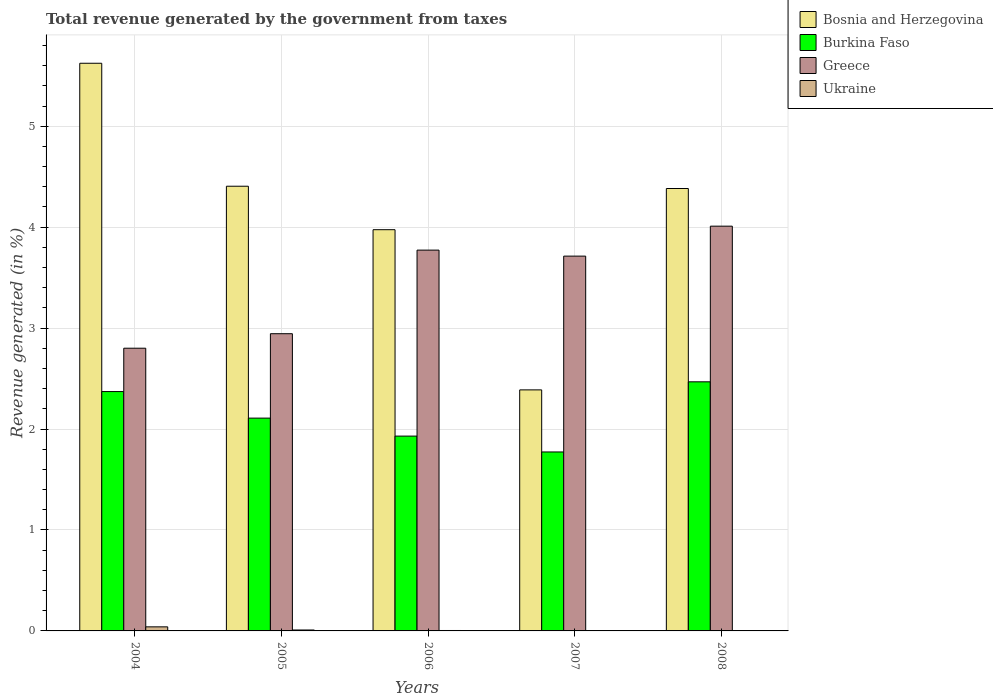How many different coloured bars are there?
Keep it short and to the point. 4. How many groups of bars are there?
Your answer should be very brief. 5. Are the number of bars on each tick of the X-axis equal?
Offer a terse response. Yes. What is the label of the 3rd group of bars from the left?
Provide a succinct answer. 2006. What is the total revenue generated in Ukraine in 2004?
Ensure brevity in your answer.  0.04. Across all years, what is the maximum total revenue generated in Burkina Faso?
Keep it short and to the point. 2.47. Across all years, what is the minimum total revenue generated in Burkina Faso?
Ensure brevity in your answer.  1.77. In which year was the total revenue generated in Burkina Faso minimum?
Keep it short and to the point. 2007. What is the total total revenue generated in Ukraine in the graph?
Your answer should be compact. 0.06. What is the difference between the total revenue generated in Greece in 2004 and that in 2006?
Offer a terse response. -0.97. What is the difference between the total revenue generated in Greece in 2007 and the total revenue generated in Burkina Faso in 2005?
Give a very brief answer. 1.6. What is the average total revenue generated in Greece per year?
Offer a terse response. 3.45. In the year 2005, what is the difference between the total revenue generated in Bosnia and Herzegovina and total revenue generated in Burkina Faso?
Your response must be concise. 2.3. In how many years, is the total revenue generated in Burkina Faso greater than 0.8 %?
Your answer should be compact. 5. What is the ratio of the total revenue generated in Ukraine in 2004 to that in 2007?
Give a very brief answer. 15.6. What is the difference between the highest and the second highest total revenue generated in Bosnia and Herzegovina?
Offer a terse response. 1.22. What is the difference between the highest and the lowest total revenue generated in Ukraine?
Provide a short and direct response. 0.04. Is the sum of the total revenue generated in Bosnia and Herzegovina in 2004 and 2008 greater than the maximum total revenue generated in Greece across all years?
Keep it short and to the point. Yes. Is it the case that in every year, the sum of the total revenue generated in Greece and total revenue generated in Burkina Faso is greater than the sum of total revenue generated in Ukraine and total revenue generated in Bosnia and Herzegovina?
Your answer should be compact. Yes. What does the 2nd bar from the left in 2008 represents?
Your answer should be compact. Burkina Faso. What does the 4th bar from the right in 2004 represents?
Give a very brief answer. Bosnia and Herzegovina. How many bars are there?
Make the answer very short. 20. Are all the bars in the graph horizontal?
Offer a terse response. No. What is the difference between two consecutive major ticks on the Y-axis?
Your response must be concise. 1. Are the values on the major ticks of Y-axis written in scientific E-notation?
Give a very brief answer. No. Does the graph contain any zero values?
Provide a succinct answer. No. Where does the legend appear in the graph?
Provide a succinct answer. Top right. How are the legend labels stacked?
Your answer should be very brief. Vertical. What is the title of the graph?
Your response must be concise. Total revenue generated by the government from taxes. Does "Mauritius" appear as one of the legend labels in the graph?
Offer a terse response. No. What is the label or title of the Y-axis?
Give a very brief answer. Revenue generated (in %). What is the Revenue generated (in %) in Bosnia and Herzegovina in 2004?
Make the answer very short. 5.62. What is the Revenue generated (in %) of Burkina Faso in 2004?
Offer a terse response. 2.37. What is the Revenue generated (in %) of Greece in 2004?
Offer a very short reply. 2.8. What is the Revenue generated (in %) of Ukraine in 2004?
Offer a very short reply. 0.04. What is the Revenue generated (in %) of Bosnia and Herzegovina in 2005?
Offer a terse response. 4.41. What is the Revenue generated (in %) of Burkina Faso in 2005?
Provide a short and direct response. 2.11. What is the Revenue generated (in %) in Greece in 2005?
Provide a succinct answer. 2.94. What is the Revenue generated (in %) in Ukraine in 2005?
Ensure brevity in your answer.  0.01. What is the Revenue generated (in %) of Bosnia and Herzegovina in 2006?
Keep it short and to the point. 3.97. What is the Revenue generated (in %) of Burkina Faso in 2006?
Your answer should be very brief. 1.93. What is the Revenue generated (in %) of Greece in 2006?
Your response must be concise. 3.77. What is the Revenue generated (in %) of Ukraine in 2006?
Your response must be concise. 0. What is the Revenue generated (in %) in Bosnia and Herzegovina in 2007?
Make the answer very short. 2.39. What is the Revenue generated (in %) of Burkina Faso in 2007?
Ensure brevity in your answer.  1.77. What is the Revenue generated (in %) in Greece in 2007?
Offer a very short reply. 3.71. What is the Revenue generated (in %) in Ukraine in 2007?
Your answer should be very brief. 0. What is the Revenue generated (in %) of Bosnia and Herzegovina in 2008?
Provide a short and direct response. 4.38. What is the Revenue generated (in %) of Burkina Faso in 2008?
Provide a succinct answer. 2.47. What is the Revenue generated (in %) in Greece in 2008?
Offer a terse response. 4.01. What is the Revenue generated (in %) of Ukraine in 2008?
Keep it short and to the point. 0. Across all years, what is the maximum Revenue generated (in %) in Bosnia and Herzegovina?
Offer a terse response. 5.62. Across all years, what is the maximum Revenue generated (in %) of Burkina Faso?
Keep it short and to the point. 2.47. Across all years, what is the maximum Revenue generated (in %) in Greece?
Ensure brevity in your answer.  4.01. Across all years, what is the maximum Revenue generated (in %) of Ukraine?
Provide a short and direct response. 0.04. Across all years, what is the minimum Revenue generated (in %) in Bosnia and Herzegovina?
Your answer should be very brief. 2.39. Across all years, what is the minimum Revenue generated (in %) of Burkina Faso?
Give a very brief answer. 1.77. Across all years, what is the minimum Revenue generated (in %) in Greece?
Your response must be concise. 2.8. Across all years, what is the minimum Revenue generated (in %) in Ukraine?
Provide a short and direct response. 0. What is the total Revenue generated (in %) in Bosnia and Herzegovina in the graph?
Offer a terse response. 20.77. What is the total Revenue generated (in %) in Burkina Faso in the graph?
Keep it short and to the point. 10.65. What is the total Revenue generated (in %) in Greece in the graph?
Your answer should be compact. 17.24. What is the total Revenue generated (in %) of Ukraine in the graph?
Give a very brief answer. 0.06. What is the difference between the Revenue generated (in %) in Bosnia and Herzegovina in 2004 and that in 2005?
Ensure brevity in your answer.  1.22. What is the difference between the Revenue generated (in %) in Burkina Faso in 2004 and that in 2005?
Your answer should be very brief. 0.26. What is the difference between the Revenue generated (in %) in Greece in 2004 and that in 2005?
Give a very brief answer. -0.14. What is the difference between the Revenue generated (in %) in Ukraine in 2004 and that in 2005?
Offer a very short reply. 0.03. What is the difference between the Revenue generated (in %) in Bosnia and Herzegovina in 2004 and that in 2006?
Your response must be concise. 1.65. What is the difference between the Revenue generated (in %) in Burkina Faso in 2004 and that in 2006?
Keep it short and to the point. 0.44. What is the difference between the Revenue generated (in %) in Greece in 2004 and that in 2006?
Keep it short and to the point. -0.97. What is the difference between the Revenue generated (in %) in Ukraine in 2004 and that in 2006?
Make the answer very short. 0.04. What is the difference between the Revenue generated (in %) of Bosnia and Herzegovina in 2004 and that in 2007?
Make the answer very short. 3.24. What is the difference between the Revenue generated (in %) in Burkina Faso in 2004 and that in 2007?
Offer a terse response. 0.6. What is the difference between the Revenue generated (in %) of Greece in 2004 and that in 2007?
Offer a terse response. -0.91. What is the difference between the Revenue generated (in %) in Ukraine in 2004 and that in 2007?
Provide a succinct answer. 0.04. What is the difference between the Revenue generated (in %) of Bosnia and Herzegovina in 2004 and that in 2008?
Make the answer very short. 1.24. What is the difference between the Revenue generated (in %) of Burkina Faso in 2004 and that in 2008?
Your response must be concise. -0.1. What is the difference between the Revenue generated (in %) of Greece in 2004 and that in 2008?
Give a very brief answer. -1.21. What is the difference between the Revenue generated (in %) in Ukraine in 2004 and that in 2008?
Offer a very short reply. 0.04. What is the difference between the Revenue generated (in %) of Bosnia and Herzegovina in 2005 and that in 2006?
Provide a succinct answer. 0.43. What is the difference between the Revenue generated (in %) of Burkina Faso in 2005 and that in 2006?
Offer a terse response. 0.18. What is the difference between the Revenue generated (in %) in Greece in 2005 and that in 2006?
Keep it short and to the point. -0.83. What is the difference between the Revenue generated (in %) in Ukraine in 2005 and that in 2006?
Your response must be concise. 0.01. What is the difference between the Revenue generated (in %) in Bosnia and Herzegovina in 2005 and that in 2007?
Offer a terse response. 2.02. What is the difference between the Revenue generated (in %) in Burkina Faso in 2005 and that in 2007?
Make the answer very short. 0.34. What is the difference between the Revenue generated (in %) of Greece in 2005 and that in 2007?
Offer a terse response. -0.77. What is the difference between the Revenue generated (in %) of Ukraine in 2005 and that in 2007?
Your answer should be very brief. 0.01. What is the difference between the Revenue generated (in %) of Bosnia and Herzegovina in 2005 and that in 2008?
Provide a succinct answer. 0.02. What is the difference between the Revenue generated (in %) of Burkina Faso in 2005 and that in 2008?
Give a very brief answer. -0.36. What is the difference between the Revenue generated (in %) in Greece in 2005 and that in 2008?
Offer a terse response. -1.07. What is the difference between the Revenue generated (in %) of Ukraine in 2005 and that in 2008?
Keep it short and to the point. 0.01. What is the difference between the Revenue generated (in %) in Bosnia and Herzegovina in 2006 and that in 2007?
Offer a terse response. 1.59. What is the difference between the Revenue generated (in %) of Burkina Faso in 2006 and that in 2007?
Offer a terse response. 0.16. What is the difference between the Revenue generated (in %) in Greece in 2006 and that in 2007?
Make the answer very short. 0.06. What is the difference between the Revenue generated (in %) of Ukraine in 2006 and that in 2007?
Offer a very short reply. 0. What is the difference between the Revenue generated (in %) of Bosnia and Herzegovina in 2006 and that in 2008?
Offer a terse response. -0.41. What is the difference between the Revenue generated (in %) of Burkina Faso in 2006 and that in 2008?
Offer a terse response. -0.54. What is the difference between the Revenue generated (in %) in Greece in 2006 and that in 2008?
Your answer should be compact. -0.24. What is the difference between the Revenue generated (in %) of Ukraine in 2006 and that in 2008?
Provide a short and direct response. 0. What is the difference between the Revenue generated (in %) of Bosnia and Herzegovina in 2007 and that in 2008?
Provide a succinct answer. -2. What is the difference between the Revenue generated (in %) in Burkina Faso in 2007 and that in 2008?
Keep it short and to the point. -0.69. What is the difference between the Revenue generated (in %) of Greece in 2007 and that in 2008?
Keep it short and to the point. -0.3. What is the difference between the Revenue generated (in %) of Ukraine in 2007 and that in 2008?
Your response must be concise. 0. What is the difference between the Revenue generated (in %) of Bosnia and Herzegovina in 2004 and the Revenue generated (in %) of Burkina Faso in 2005?
Offer a very short reply. 3.52. What is the difference between the Revenue generated (in %) in Bosnia and Herzegovina in 2004 and the Revenue generated (in %) in Greece in 2005?
Offer a very short reply. 2.68. What is the difference between the Revenue generated (in %) in Bosnia and Herzegovina in 2004 and the Revenue generated (in %) in Ukraine in 2005?
Provide a short and direct response. 5.61. What is the difference between the Revenue generated (in %) of Burkina Faso in 2004 and the Revenue generated (in %) of Greece in 2005?
Give a very brief answer. -0.57. What is the difference between the Revenue generated (in %) in Burkina Faso in 2004 and the Revenue generated (in %) in Ukraine in 2005?
Keep it short and to the point. 2.36. What is the difference between the Revenue generated (in %) in Greece in 2004 and the Revenue generated (in %) in Ukraine in 2005?
Offer a terse response. 2.79. What is the difference between the Revenue generated (in %) of Bosnia and Herzegovina in 2004 and the Revenue generated (in %) of Burkina Faso in 2006?
Your response must be concise. 3.69. What is the difference between the Revenue generated (in %) in Bosnia and Herzegovina in 2004 and the Revenue generated (in %) in Greece in 2006?
Offer a terse response. 1.85. What is the difference between the Revenue generated (in %) in Bosnia and Herzegovina in 2004 and the Revenue generated (in %) in Ukraine in 2006?
Ensure brevity in your answer.  5.62. What is the difference between the Revenue generated (in %) of Burkina Faso in 2004 and the Revenue generated (in %) of Greece in 2006?
Keep it short and to the point. -1.4. What is the difference between the Revenue generated (in %) in Burkina Faso in 2004 and the Revenue generated (in %) in Ukraine in 2006?
Your answer should be very brief. 2.37. What is the difference between the Revenue generated (in %) in Greece in 2004 and the Revenue generated (in %) in Ukraine in 2006?
Make the answer very short. 2.8. What is the difference between the Revenue generated (in %) of Bosnia and Herzegovina in 2004 and the Revenue generated (in %) of Burkina Faso in 2007?
Your answer should be compact. 3.85. What is the difference between the Revenue generated (in %) in Bosnia and Herzegovina in 2004 and the Revenue generated (in %) in Greece in 2007?
Provide a short and direct response. 1.91. What is the difference between the Revenue generated (in %) in Bosnia and Herzegovina in 2004 and the Revenue generated (in %) in Ukraine in 2007?
Offer a very short reply. 5.62. What is the difference between the Revenue generated (in %) in Burkina Faso in 2004 and the Revenue generated (in %) in Greece in 2007?
Provide a short and direct response. -1.34. What is the difference between the Revenue generated (in %) in Burkina Faso in 2004 and the Revenue generated (in %) in Ukraine in 2007?
Keep it short and to the point. 2.37. What is the difference between the Revenue generated (in %) in Greece in 2004 and the Revenue generated (in %) in Ukraine in 2007?
Your answer should be very brief. 2.8. What is the difference between the Revenue generated (in %) in Bosnia and Herzegovina in 2004 and the Revenue generated (in %) in Burkina Faso in 2008?
Give a very brief answer. 3.16. What is the difference between the Revenue generated (in %) in Bosnia and Herzegovina in 2004 and the Revenue generated (in %) in Greece in 2008?
Keep it short and to the point. 1.61. What is the difference between the Revenue generated (in %) in Bosnia and Herzegovina in 2004 and the Revenue generated (in %) in Ukraine in 2008?
Make the answer very short. 5.62. What is the difference between the Revenue generated (in %) in Burkina Faso in 2004 and the Revenue generated (in %) in Greece in 2008?
Your answer should be compact. -1.64. What is the difference between the Revenue generated (in %) of Burkina Faso in 2004 and the Revenue generated (in %) of Ukraine in 2008?
Your answer should be very brief. 2.37. What is the difference between the Revenue generated (in %) in Greece in 2004 and the Revenue generated (in %) in Ukraine in 2008?
Your answer should be compact. 2.8. What is the difference between the Revenue generated (in %) in Bosnia and Herzegovina in 2005 and the Revenue generated (in %) in Burkina Faso in 2006?
Your answer should be very brief. 2.48. What is the difference between the Revenue generated (in %) of Bosnia and Herzegovina in 2005 and the Revenue generated (in %) of Greece in 2006?
Ensure brevity in your answer.  0.63. What is the difference between the Revenue generated (in %) of Bosnia and Herzegovina in 2005 and the Revenue generated (in %) of Ukraine in 2006?
Give a very brief answer. 4.4. What is the difference between the Revenue generated (in %) in Burkina Faso in 2005 and the Revenue generated (in %) in Greece in 2006?
Your answer should be very brief. -1.66. What is the difference between the Revenue generated (in %) of Burkina Faso in 2005 and the Revenue generated (in %) of Ukraine in 2006?
Make the answer very short. 2.1. What is the difference between the Revenue generated (in %) in Greece in 2005 and the Revenue generated (in %) in Ukraine in 2006?
Your answer should be compact. 2.94. What is the difference between the Revenue generated (in %) in Bosnia and Herzegovina in 2005 and the Revenue generated (in %) in Burkina Faso in 2007?
Your response must be concise. 2.63. What is the difference between the Revenue generated (in %) in Bosnia and Herzegovina in 2005 and the Revenue generated (in %) in Greece in 2007?
Provide a short and direct response. 0.69. What is the difference between the Revenue generated (in %) in Bosnia and Herzegovina in 2005 and the Revenue generated (in %) in Ukraine in 2007?
Keep it short and to the point. 4.4. What is the difference between the Revenue generated (in %) of Burkina Faso in 2005 and the Revenue generated (in %) of Greece in 2007?
Offer a terse response. -1.6. What is the difference between the Revenue generated (in %) in Burkina Faso in 2005 and the Revenue generated (in %) in Ukraine in 2007?
Offer a terse response. 2.11. What is the difference between the Revenue generated (in %) of Greece in 2005 and the Revenue generated (in %) of Ukraine in 2007?
Your response must be concise. 2.94. What is the difference between the Revenue generated (in %) of Bosnia and Herzegovina in 2005 and the Revenue generated (in %) of Burkina Faso in 2008?
Your answer should be very brief. 1.94. What is the difference between the Revenue generated (in %) of Bosnia and Herzegovina in 2005 and the Revenue generated (in %) of Greece in 2008?
Give a very brief answer. 0.4. What is the difference between the Revenue generated (in %) of Bosnia and Herzegovina in 2005 and the Revenue generated (in %) of Ukraine in 2008?
Give a very brief answer. 4.4. What is the difference between the Revenue generated (in %) in Burkina Faso in 2005 and the Revenue generated (in %) in Greece in 2008?
Provide a succinct answer. -1.9. What is the difference between the Revenue generated (in %) in Burkina Faso in 2005 and the Revenue generated (in %) in Ukraine in 2008?
Provide a short and direct response. 2.11. What is the difference between the Revenue generated (in %) of Greece in 2005 and the Revenue generated (in %) of Ukraine in 2008?
Offer a terse response. 2.94. What is the difference between the Revenue generated (in %) in Bosnia and Herzegovina in 2006 and the Revenue generated (in %) in Burkina Faso in 2007?
Provide a succinct answer. 2.2. What is the difference between the Revenue generated (in %) in Bosnia and Herzegovina in 2006 and the Revenue generated (in %) in Greece in 2007?
Provide a succinct answer. 0.26. What is the difference between the Revenue generated (in %) of Bosnia and Herzegovina in 2006 and the Revenue generated (in %) of Ukraine in 2007?
Keep it short and to the point. 3.97. What is the difference between the Revenue generated (in %) in Burkina Faso in 2006 and the Revenue generated (in %) in Greece in 2007?
Offer a terse response. -1.78. What is the difference between the Revenue generated (in %) of Burkina Faso in 2006 and the Revenue generated (in %) of Ukraine in 2007?
Provide a succinct answer. 1.93. What is the difference between the Revenue generated (in %) of Greece in 2006 and the Revenue generated (in %) of Ukraine in 2007?
Keep it short and to the point. 3.77. What is the difference between the Revenue generated (in %) in Bosnia and Herzegovina in 2006 and the Revenue generated (in %) in Burkina Faso in 2008?
Offer a terse response. 1.51. What is the difference between the Revenue generated (in %) in Bosnia and Herzegovina in 2006 and the Revenue generated (in %) in Greece in 2008?
Provide a short and direct response. -0.04. What is the difference between the Revenue generated (in %) in Bosnia and Herzegovina in 2006 and the Revenue generated (in %) in Ukraine in 2008?
Your answer should be compact. 3.97. What is the difference between the Revenue generated (in %) in Burkina Faso in 2006 and the Revenue generated (in %) in Greece in 2008?
Your answer should be compact. -2.08. What is the difference between the Revenue generated (in %) in Burkina Faso in 2006 and the Revenue generated (in %) in Ukraine in 2008?
Make the answer very short. 1.93. What is the difference between the Revenue generated (in %) of Greece in 2006 and the Revenue generated (in %) of Ukraine in 2008?
Make the answer very short. 3.77. What is the difference between the Revenue generated (in %) in Bosnia and Herzegovina in 2007 and the Revenue generated (in %) in Burkina Faso in 2008?
Make the answer very short. -0.08. What is the difference between the Revenue generated (in %) of Bosnia and Herzegovina in 2007 and the Revenue generated (in %) of Greece in 2008?
Offer a very short reply. -1.62. What is the difference between the Revenue generated (in %) in Bosnia and Herzegovina in 2007 and the Revenue generated (in %) in Ukraine in 2008?
Your answer should be compact. 2.39. What is the difference between the Revenue generated (in %) of Burkina Faso in 2007 and the Revenue generated (in %) of Greece in 2008?
Your answer should be compact. -2.24. What is the difference between the Revenue generated (in %) in Burkina Faso in 2007 and the Revenue generated (in %) in Ukraine in 2008?
Keep it short and to the point. 1.77. What is the difference between the Revenue generated (in %) of Greece in 2007 and the Revenue generated (in %) of Ukraine in 2008?
Keep it short and to the point. 3.71. What is the average Revenue generated (in %) in Bosnia and Herzegovina per year?
Provide a short and direct response. 4.16. What is the average Revenue generated (in %) in Burkina Faso per year?
Provide a short and direct response. 2.13. What is the average Revenue generated (in %) in Greece per year?
Keep it short and to the point. 3.45. What is the average Revenue generated (in %) in Ukraine per year?
Ensure brevity in your answer.  0.01. In the year 2004, what is the difference between the Revenue generated (in %) of Bosnia and Herzegovina and Revenue generated (in %) of Burkina Faso?
Keep it short and to the point. 3.25. In the year 2004, what is the difference between the Revenue generated (in %) in Bosnia and Herzegovina and Revenue generated (in %) in Greece?
Give a very brief answer. 2.82. In the year 2004, what is the difference between the Revenue generated (in %) in Bosnia and Herzegovina and Revenue generated (in %) in Ukraine?
Give a very brief answer. 5.58. In the year 2004, what is the difference between the Revenue generated (in %) in Burkina Faso and Revenue generated (in %) in Greece?
Your answer should be very brief. -0.43. In the year 2004, what is the difference between the Revenue generated (in %) in Burkina Faso and Revenue generated (in %) in Ukraine?
Offer a terse response. 2.33. In the year 2004, what is the difference between the Revenue generated (in %) of Greece and Revenue generated (in %) of Ukraine?
Offer a very short reply. 2.76. In the year 2005, what is the difference between the Revenue generated (in %) in Bosnia and Herzegovina and Revenue generated (in %) in Burkina Faso?
Your answer should be compact. 2.3. In the year 2005, what is the difference between the Revenue generated (in %) of Bosnia and Herzegovina and Revenue generated (in %) of Greece?
Keep it short and to the point. 1.46. In the year 2005, what is the difference between the Revenue generated (in %) in Bosnia and Herzegovina and Revenue generated (in %) in Ukraine?
Ensure brevity in your answer.  4.4. In the year 2005, what is the difference between the Revenue generated (in %) of Burkina Faso and Revenue generated (in %) of Greece?
Ensure brevity in your answer.  -0.84. In the year 2005, what is the difference between the Revenue generated (in %) in Burkina Faso and Revenue generated (in %) in Ukraine?
Provide a succinct answer. 2.1. In the year 2005, what is the difference between the Revenue generated (in %) in Greece and Revenue generated (in %) in Ukraine?
Provide a succinct answer. 2.94. In the year 2006, what is the difference between the Revenue generated (in %) in Bosnia and Herzegovina and Revenue generated (in %) in Burkina Faso?
Ensure brevity in your answer.  2.04. In the year 2006, what is the difference between the Revenue generated (in %) of Bosnia and Herzegovina and Revenue generated (in %) of Greece?
Your answer should be compact. 0.2. In the year 2006, what is the difference between the Revenue generated (in %) in Bosnia and Herzegovina and Revenue generated (in %) in Ukraine?
Keep it short and to the point. 3.97. In the year 2006, what is the difference between the Revenue generated (in %) in Burkina Faso and Revenue generated (in %) in Greece?
Provide a succinct answer. -1.84. In the year 2006, what is the difference between the Revenue generated (in %) of Burkina Faso and Revenue generated (in %) of Ukraine?
Your answer should be compact. 1.93. In the year 2006, what is the difference between the Revenue generated (in %) in Greece and Revenue generated (in %) in Ukraine?
Keep it short and to the point. 3.77. In the year 2007, what is the difference between the Revenue generated (in %) of Bosnia and Herzegovina and Revenue generated (in %) of Burkina Faso?
Provide a succinct answer. 0.61. In the year 2007, what is the difference between the Revenue generated (in %) of Bosnia and Herzegovina and Revenue generated (in %) of Greece?
Your answer should be compact. -1.33. In the year 2007, what is the difference between the Revenue generated (in %) of Bosnia and Herzegovina and Revenue generated (in %) of Ukraine?
Your answer should be compact. 2.39. In the year 2007, what is the difference between the Revenue generated (in %) in Burkina Faso and Revenue generated (in %) in Greece?
Ensure brevity in your answer.  -1.94. In the year 2007, what is the difference between the Revenue generated (in %) of Burkina Faso and Revenue generated (in %) of Ukraine?
Offer a very short reply. 1.77. In the year 2007, what is the difference between the Revenue generated (in %) of Greece and Revenue generated (in %) of Ukraine?
Your response must be concise. 3.71. In the year 2008, what is the difference between the Revenue generated (in %) in Bosnia and Herzegovina and Revenue generated (in %) in Burkina Faso?
Offer a very short reply. 1.92. In the year 2008, what is the difference between the Revenue generated (in %) in Bosnia and Herzegovina and Revenue generated (in %) in Greece?
Offer a very short reply. 0.37. In the year 2008, what is the difference between the Revenue generated (in %) of Bosnia and Herzegovina and Revenue generated (in %) of Ukraine?
Give a very brief answer. 4.38. In the year 2008, what is the difference between the Revenue generated (in %) in Burkina Faso and Revenue generated (in %) in Greece?
Make the answer very short. -1.54. In the year 2008, what is the difference between the Revenue generated (in %) in Burkina Faso and Revenue generated (in %) in Ukraine?
Offer a terse response. 2.47. In the year 2008, what is the difference between the Revenue generated (in %) of Greece and Revenue generated (in %) of Ukraine?
Offer a very short reply. 4.01. What is the ratio of the Revenue generated (in %) in Bosnia and Herzegovina in 2004 to that in 2005?
Your answer should be very brief. 1.28. What is the ratio of the Revenue generated (in %) of Burkina Faso in 2004 to that in 2005?
Give a very brief answer. 1.12. What is the ratio of the Revenue generated (in %) in Greece in 2004 to that in 2005?
Ensure brevity in your answer.  0.95. What is the ratio of the Revenue generated (in %) in Ukraine in 2004 to that in 2005?
Provide a short and direct response. 4.38. What is the ratio of the Revenue generated (in %) in Bosnia and Herzegovina in 2004 to that in 2006?
Give a very brief answer. 1.41. What is the ratio of the Revenue generated (in %) of Burkina Faso in 2004 to that in 2006?
Make the answer very short. 1.23. What is the ratio of the Revenue generated (in %) in Greece in 2004 to that in 2006?
Keep it short and to the point. 0.74. What is the ratio of the Revenue generated (in %) of Ukraine in 2004 to that in 2006?
Offer a terse response. 9.53. What is the ratio of the Revenue generated (in %) in Bosnia and Herzegovina in 2004 to that in 2007?
Make the answer very short. 2.36. What is the ratio of the Revenue generated (in %) in Burkina Faso in 2004 to that in 2007?
Provide a short and direct response. 1.34. What is the ratio of the Revenue generated (in %) of Greece in 2004 to that in 2007?
Provide a short and direct response. 0.75. What is the ratio of the Revenue generated (in %) of Ukraine in 2004 to that in 2007?
Your answer should be compact. 15.6. What is the ratio of the Revenue generated (in %) of Bosnia and Herzegovina in 2004 to that in 2008?
Your answer should be very brief. 1.28. What is the ratio of the Revenue generated (in %) in Burkina Faso in 2004 to that in 2008?
Your answer should be compact. 0.96. What is the ratio of the Revenue generated (in %) of Greece in 2004 to that in 2008?
Keep it short and to the point. 0.7. What is the ratio of the Revenue generated (in %) of Ukraine in 2004 to that in 2008?
Ensure brevity in your answer.  40.67. What is the ratio of the Revenue generated (in %) of Bosnia and Herzegovina in 2005 to that in 2006?
Your answer should be very brief. 1.11. What is the ratio of the Revenue generated (in %) of Burkina Faso in 2005 to that in 2006?
Ensure brevity in your answer.  1.09. What is the ratio of the Revenue generated (in %) of Greece in 2005 to that in 2006?
Your answer should be compact. 0.78. What is the ratio of the Revenue generated (in %) in Ukraine in 2005 to that in 2006?
Provide a succinct answer. 2.18. What is the ratio of the Revenue generated (in %) of Bosnia and Herzegovina in 2005 to that in 2007?
Make the answer very short. 1.84. What is the ratio of the Revenue generated (in %) in Burkina Faso in 2005 to that in 2007?
Your answer should be very brief. 1.19. What is the ratio of the Revenue generated (in %) of Greece in 2005 to that in 2007?
Your response must be concise. 0.79. What is the ratio of the Revenue generated (in %) in Ukraine in 2005 to that in 2007?
Your answer should be compact. 3.56. What is the ratio of the Revenue generated (in %) in Burkina Faso in 2005 to that in 2008?
Offer a terse response. 0.85. What is the ratio of the Revenue generated (in %) in Greece in 2005 to that in 2008?
Provide a short and direct response. 0.73. What is the ratio of the Revenue generated (in %) in Ukraine in 2005 to that in 2008?
Offer a terse response. 9.28. What is the ratio of the Revenue generated (in %) of Bosnia and Herzegovina in 2006 to that in 2007?
Provide a succinct answer. 1.66. What is the ratio of the Revenue generated (in %) of Burkina Faso in 2006 to that in 2007?
Offer a terse response. 1.09. What is the ratio of the Revenue generated (in %) in Greece in 2006 to that in 2007?
Give a very brief answer. 1.02. What is the ratio of the Revenue generated (in %) of Ukraine in 2006 to that in 2007?
Your response must be concise. 1.64. What is the ratio of the Revenue generated (in %) of Bosnia and Herzegovina in 2006 to that in 2008?
Your answer should be very brief. 0.91. What is the ratio of the Revenue generated (in %) of Burkina Faso in 2006 to that in 2008?
Ensure brevity in your answer.  0.78. What is the ratio of the Revenue generated (in %) in Greece in 2006 to that in 2008?
Your answer should be compact. 0.94. What is the ratio of the Revenue generated (in %) of Ukraine in 2006 to that in 2008?
Keep it short and to the point. 4.27. What is the ratio of the Revenue generated (in %) in Bosnia and Herzegovina in 2007 to that in 2008?
Your response must be concise. 0.54. What is the ratio of the Revenue generated (in %) in Burkina Faso in 2007 to that in 2008?
Offer a terse response. 0.72. What is the ratio of the Revenue generated (in %) in Greece in 2007 to that in 2008?
Your answer should be compact. 0.93. What is the ratio of the Revenue generated (in %) of Ukraine in 2007 to that in 2008?
Your answer should be compact. 2.61. What is the difference between the highest and the second highest Revenue generated (in %) of Bosnia and Herzegovina?
Provide a short and direct response. 1.22. What is the difference between the highest and the second highest Revenue generated (in %) in Burkina Faso?
Make the answer very short. 0.1. What is the difference between the highest and the second highest Revenue generated (in %) in Greece?
Offer a very short reply. 0.24. What is the difference between the highest and the second highest Revenue generated (in %) of Ukraine?
Provide a short and direct response. 0.03. What is the difference between the highest and the lowest Revenue generated (in %) of Bosnia and Herzegovina?
Your response must be concise. 3.24. What is the difference between the highest and the lowest Revenue generated (in %) in Burkina Faso?
Your response must be concise. 0.69. What is the difference between the highest and the lowest Revenue generated (in %) in Greece?
Your answer should be compact. 1.21. What is the difference between the highest and the lowest Revenue generated (in %) in Ukraine?
Give a very brief answer. 0.04. 